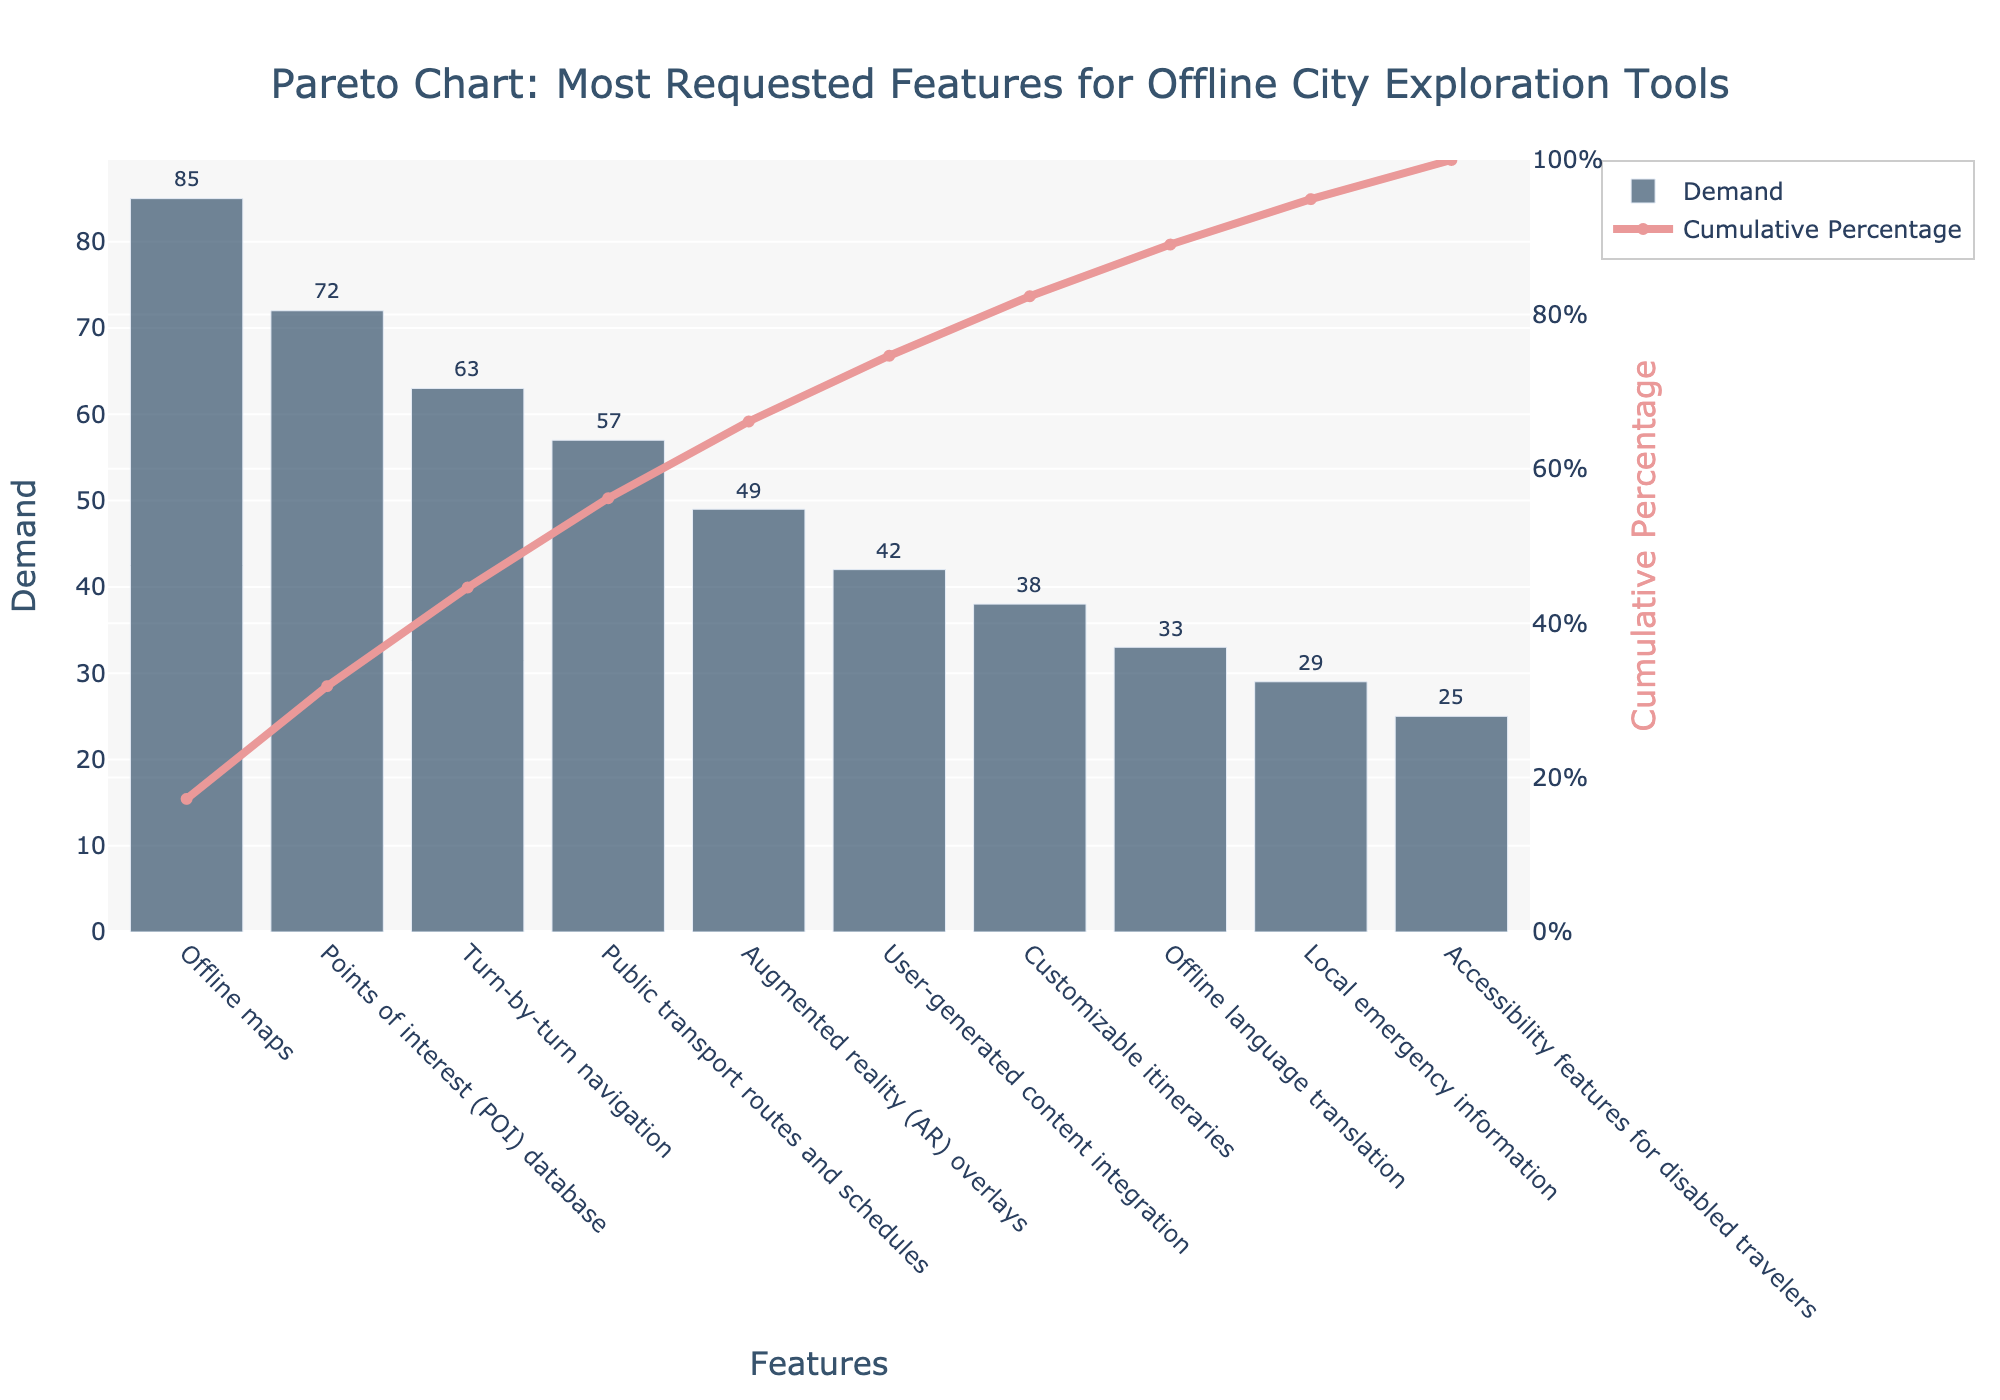What is the most requested feature for offline city exploration tools? The most requested feature is the one with the highest demand shown by the tallest bar in the chart, labeled "Offline maps" with a demand of 85.
Answer: Offline maps What percentage of the total demand is covered by the top three requested features? The percentage is found by summing up the demands of the top three features (Offline maps: 85, Points of interest database: 72, Turn-by-turn navigation: 63) and then dividing by the total demand (85 + 72 + 63 + 57 + 49 + 42 + 38 + 33 + 29 + 25 = 493), and finally multiplying by 100 to get the percentage: ((85+72+63) / 493) * 100 = 44.6%.
Answer: 44.6% Between "Public transport routes and schedules" and "Augmented reality overlays", which feature has higher demand and by how much? "Public transport routes and schedules" has higher demand. The demand for "Public transport routes and schedules" is 57, and for "Augmented reality overlays" it is 49. The difference is 57 - 49 = 8.
Answer: Public transport routes and schedules by 8 How many features are needed to reach at least 80% of total demand? To reach at least 80%, we sum the cumulative percentages until we reach or pass 80%. Starting from the top:
"Offline maps" (85) alone is 17.2%, 
adding "Points of interest (72)" is 31.8%, 
adding "Turn-by-turn navigation (63)" is 44.6%, 
adding "Public transport routes and schedules (57)" is 56.2%, 
adding "Augmented reality overlays (49)" is 66.1%, 
adding "User-generated content integration (42)" is 74.7%, 
adding "Customizable itineraries (38)" is 82.4%. Thus, 7 features are needed.
Answer: 7 Which feature has the least demand, and what is its cumulative percentage? The feature with the least demand is "Accessibility features for disabled travelers" with a demand of 25. Its cumulative percentage is 100% (as it is the last in the descending order).
Answer: Accessibility features for disabled travelers, 100% What is the demand difference between the feature with the highest demand and the feature with the lowest demand? The highest demand feature is "Offline maps" with 85, and the lowest demand feature is "Accessibility features for disabled travelers" with 25. The difference is 85 - 25 = 60.
Answer: 60 What is the cumulative percentage after including "User-generated content integration"? Adding the demand for each feature up to "User-generated content integration" (85 + 72 + 63 + 57 + 49 + 42) gives 368. The total demand is 493. So, the cumulative percentage is (368 / 493) * 100 = 74.7%.
Answer: 74.7% 